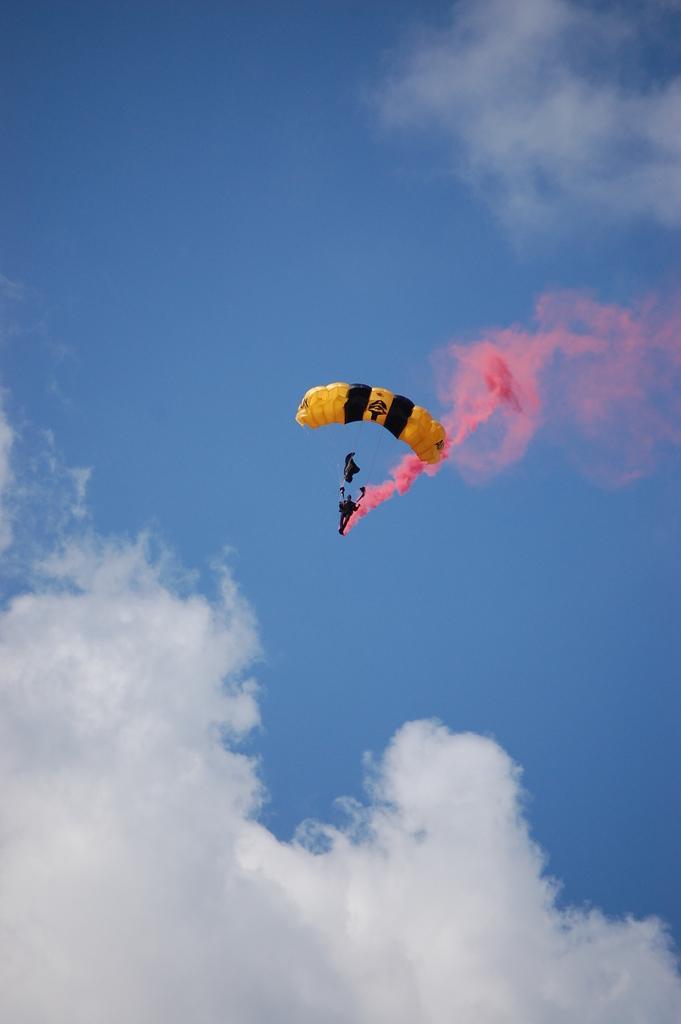How would you summarize this image in a sentence or two? In this picture we can see a parachute in the air and we can see clouds. 